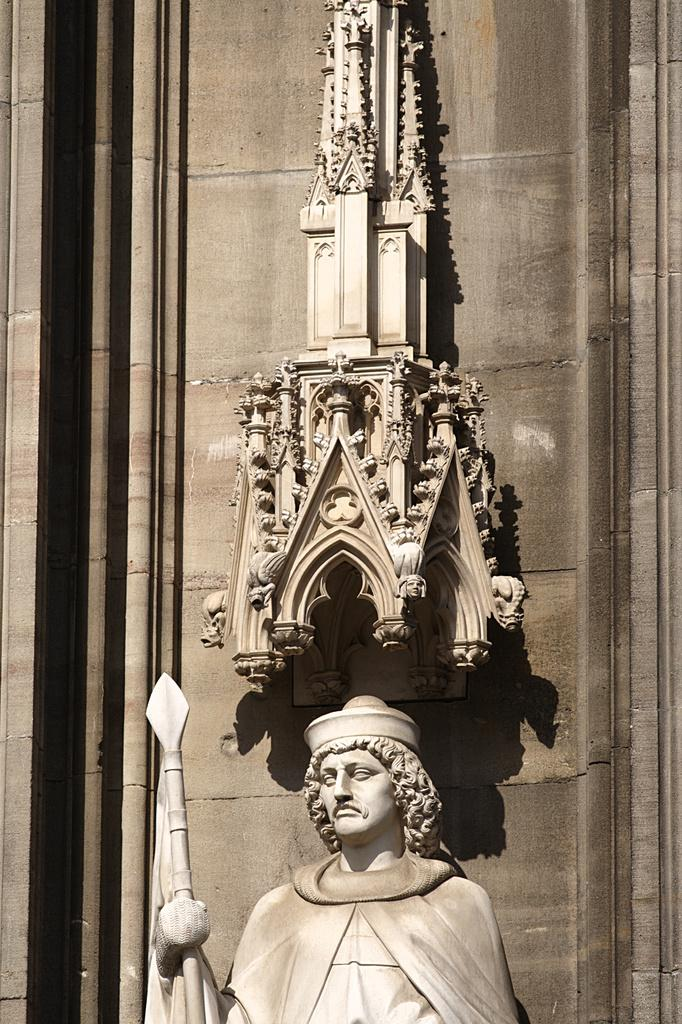What can be seen in the image? There are two idols in the image. Where are the idols located? The idols are placed in front of a wall. Who is the owner of the pets in the image? There are no pets present in the image, so it is not possible to determine the owner. 